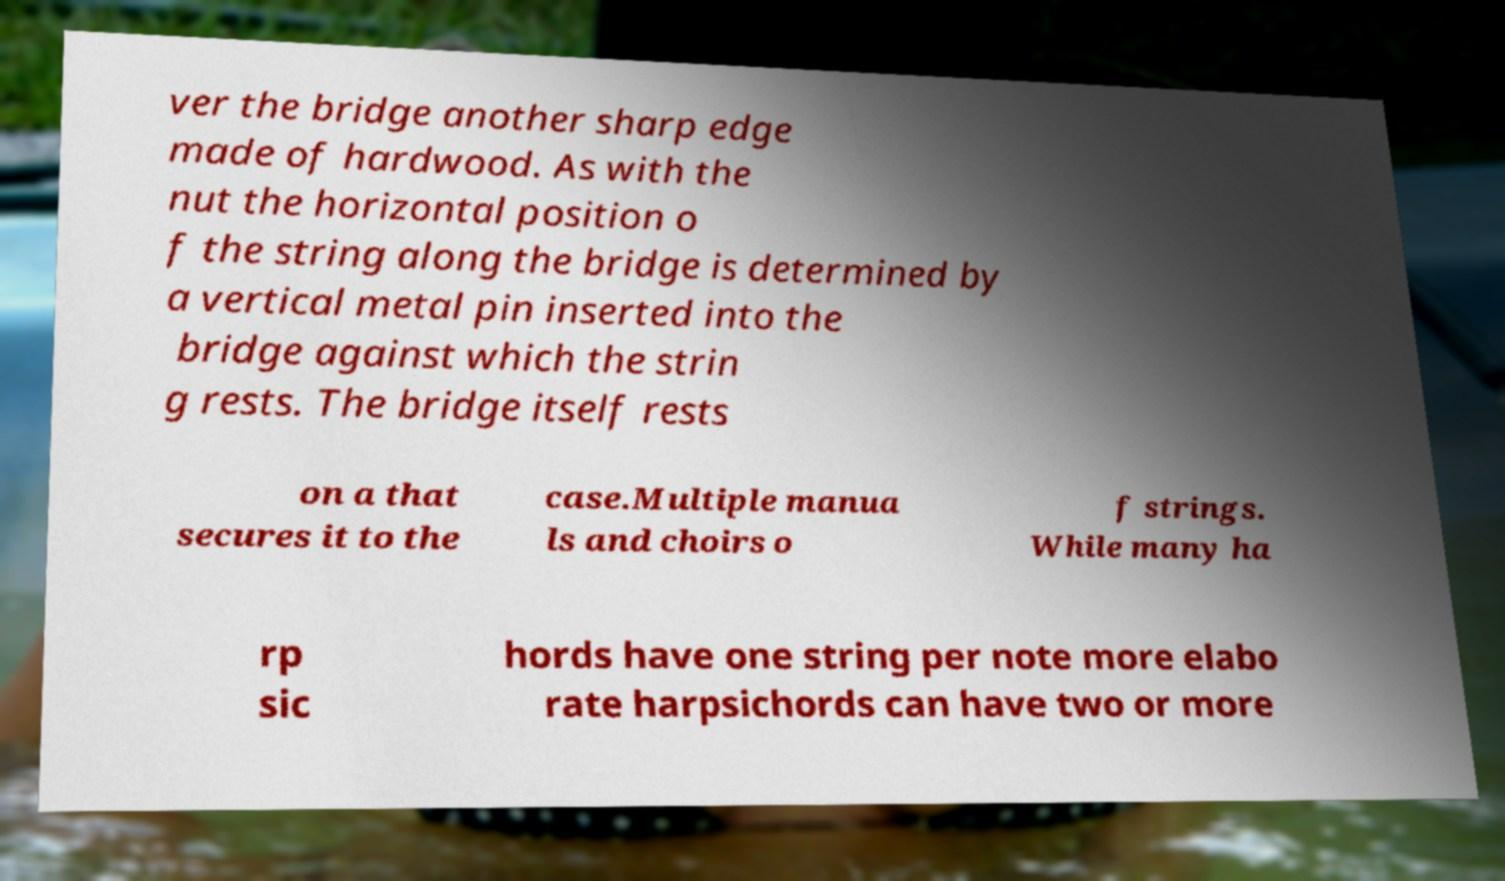For documentation purposes, I need the text within this image transcribed. Could you provide that? ver the bridge another sharp edge made of hardwood. As with the nut the horizontal position o f the string along the bridge is determined by a vertical metal pin inserted into the bridge against which the strin g rests. The bridge itself rests on a that secures it to the case.Multiple manua ls and choirs o f strings. While many ha rp sic hords have one string per note more elabo rate harpsichords can have two or more 